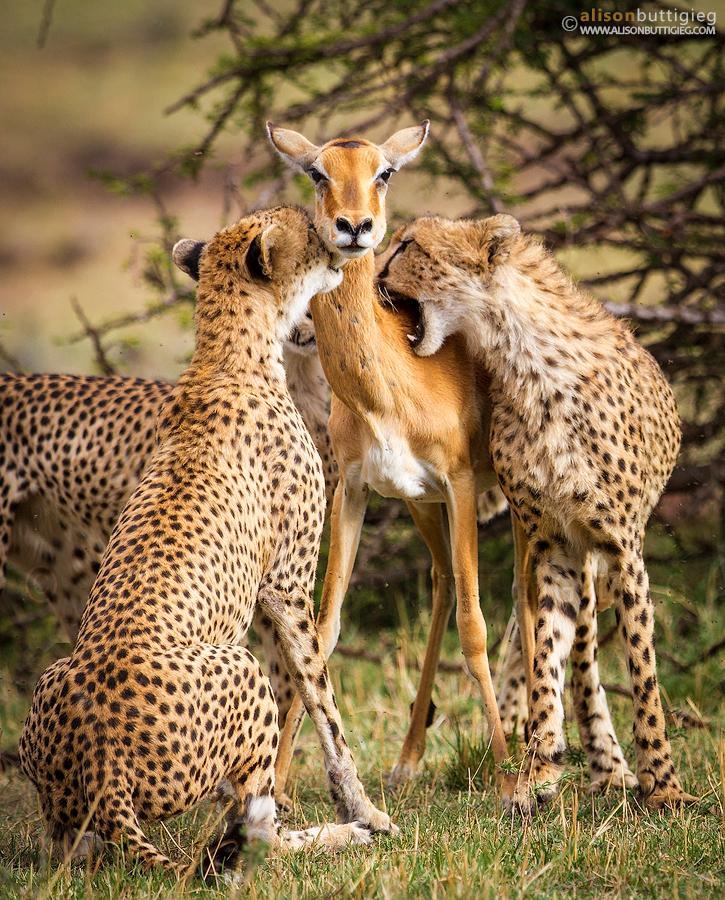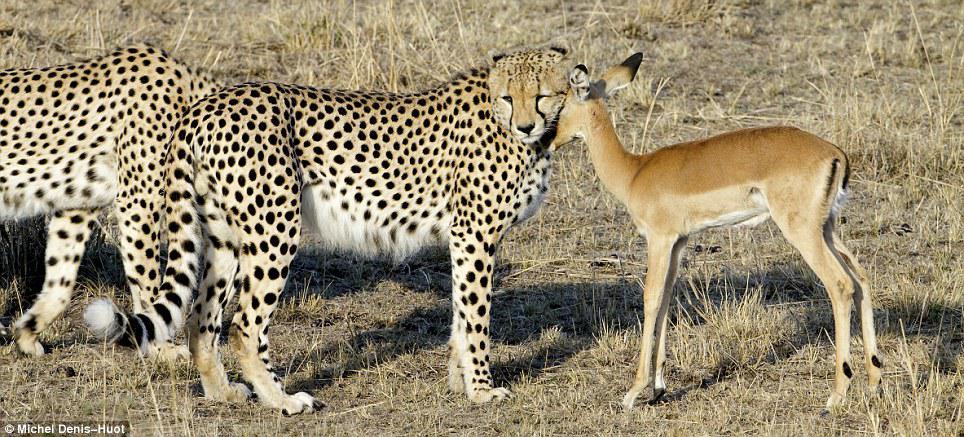The first image is the image on the left, the second image is the image on the right. For the images displayed, is the sentence "In one image there is a pair of cheetahs biting an antelope on the neck." factually correct? Answer yes or no. Yes. 